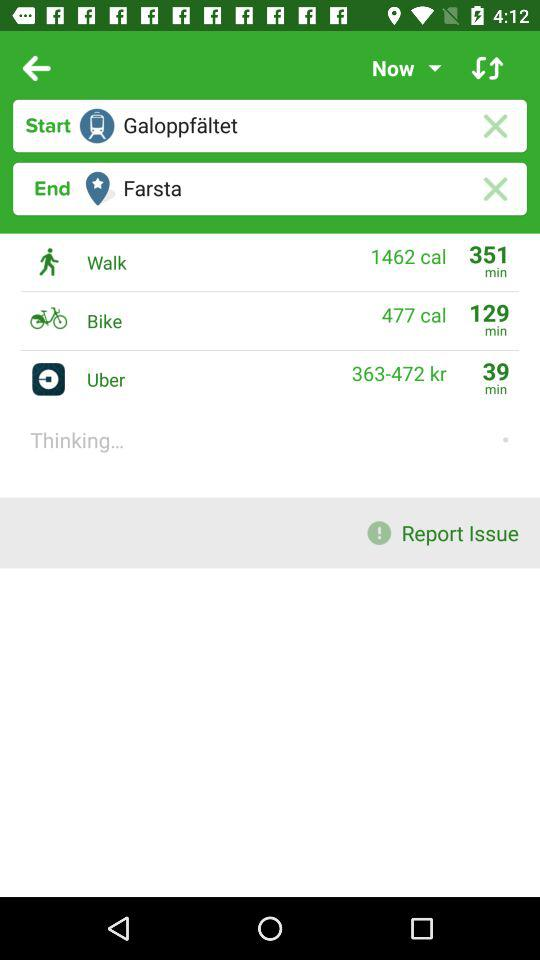How much time will Uber take? Uber will take 39 minutes. 